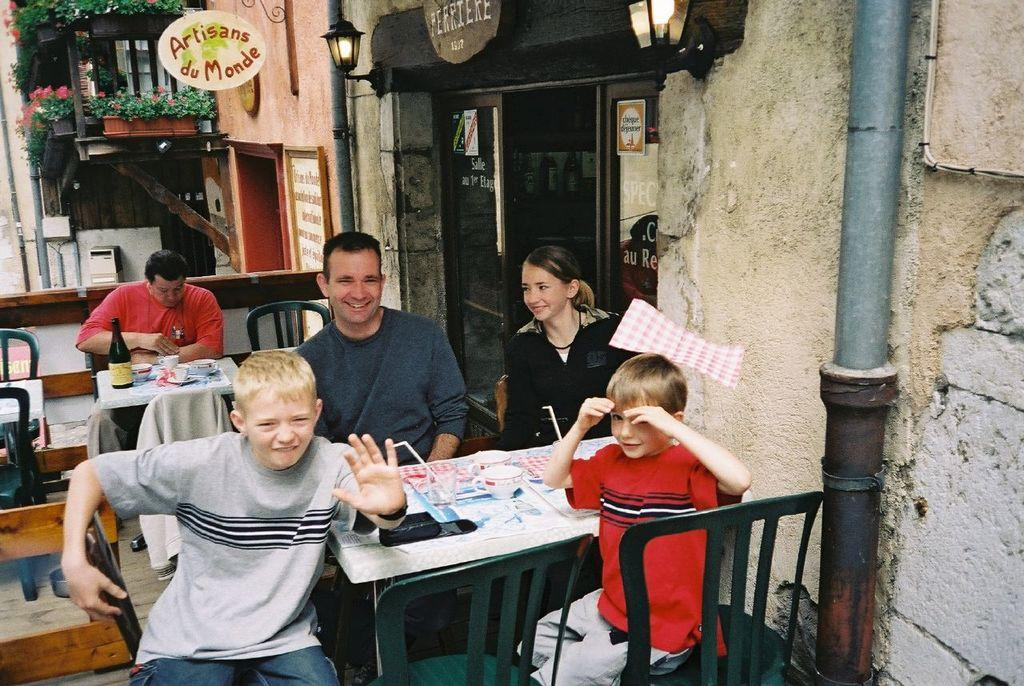How many people are sitting on chairs in the image? There are four people sitting on chairs in the image. What expressions do the people have? The four people are smiling. Can you describe the man sitting in the background? There is a man sitting on a chair in the background, and he is having coffee and a drink. Can you see a rabbit hopping in the image? There is no rabbit present in the image. Is it raining in the image? The image does not show any indication of rain. 